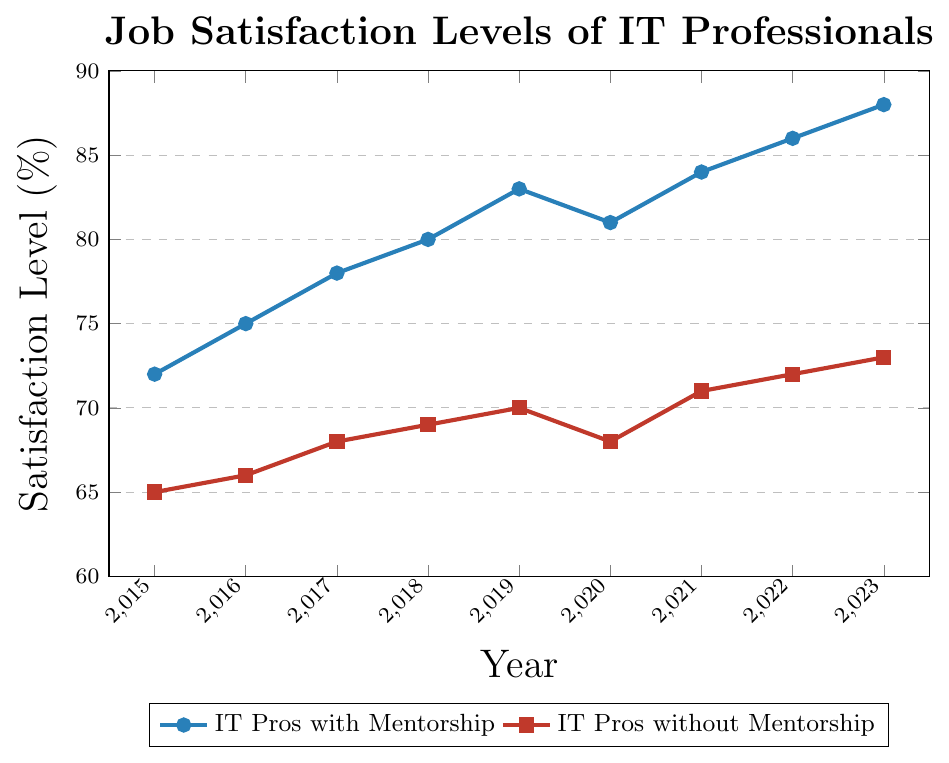What is the job satisfaction level difference between IT professionals with mentorship and those without mentorship in 2015? In 2015, the job satisfaction level for those with mentorship is 72%, while for those without mentorship it's 65%. The difference is calculated as 72% - 65%.
Answer: 7% What year did IT professionals with mentorship have the lowest job satisfaction level, and what was the level? From the chart, the lowest job satisfaction level for IT professionals with mentorship was in 2020 with a value of 81%.
Answer: 2020, 81% Which year saw the highest increase in job satisfaction level for IT professionals without mentorship compared to the previous year? Analyzing the data points, the highest increase happened between 2020 and 2021, where the satisfaction level increased from 68% to 71%, which is an increase of 3%.
Answer: 2021 By how much did the job satisfaction level of IT professionals with mentorship change from 2019 to 2022? From the figure, the job satisfaction level of IT professionals with mentorship was 83% in 2019 and 86% in 2022. The change is calculated as 86% - 83%.
Answer: 3% In which year did both groups (with and without mentorship) have the same satisfaction level trend such as both increasing or both decreasing? Both groups experienced a decrease in job satisfaction level in the year 2020. The satisfaction levels in 2019 and 2021 for both groups were higher than in 2020.
Answer: 2020 What is the overall trend of job satisfaction levels for IT professionals with mentorship from 2015 to 2023? The job satisfaction levels for IT professionals with mentorship showed an overall increasing trend from 72% in 2015 to 88% in 2023, despite a minor dip in 2020.
Answer: Increasing How many years did the satisfaction level for IT professionals without mentorship remain below 70%? From the figure, the job satisfaction levels for IT professionals without mentorship were below 70% from 2015 to 2019 and again in 2020. This comprises 6 years (2015, 2016, 2017, 2018, 2019, and 2020).
Answer: 6 years In which years was the difference in job satisfaction between professionals with and without mentorship exactly 8%? By examining the chart, the years with an exact 8% difference were 2016 and 2017. In 2016: 75% (with mentorship) and 66% (without mentorship) both lead to a difference of 9%, and in 2017: 78% (with mentorship) and 68% (without mentorship) both lead to a difference of 10%.
Answer: None What visual characteristic distinguishes the data points of IT professionals with mentorship from those without mentorship? The data points for IT professionals with mentorship are marked with circles, while those without mentorship are marked with squares.
Answer: Marker shape What is the average job satisfaction level of IT professionals with mentorship over the given time period? Adding the satisfaction levels for professionals with mentorship from 2015 to 2023: (72 + 75 + 78 + 80 + 83 + 81 + 84 + 86 + 88) and then dividing by the number of years (9) gives (727/9).
Answer: 80.78% 